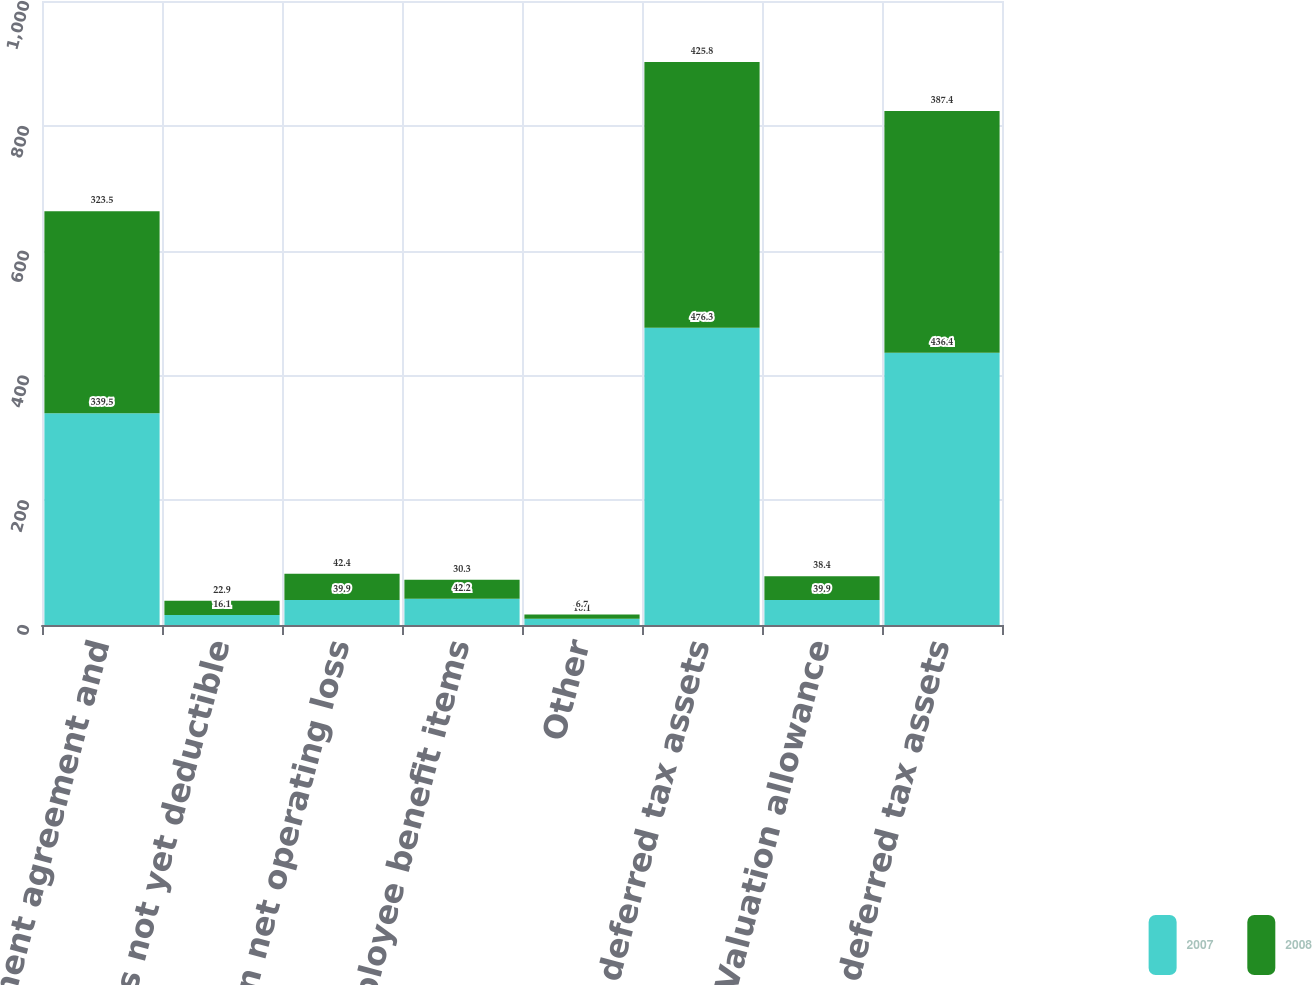Convert chart. <chart><loc_0><loc_0><loc_500><loc_500><stacked_bar_chart><ecel><fcel>Settlement agreement and<fcel>Accruals not yet deductible<fcel>Foreign net operating loss<fcel>Employee benefit items<fcel>Other<fcel>Gross deferred tax assets<fcel>Valuation allowance<fcel>Total deferred tax assets<nl><fcel>2007<fcel>339.5<fcel>16.1<fcel>39.9<fcel>42.2<fcel>10.1<fcel>476.3<fcel>39.9<fcel>436.4<nl><fcel>2008<fcel>323.5<fcel>22.9<fcel>42.4<fcel>30.3<fcel>6.7<fcel>425.8<fcel>38.4<fcel>387.4<nl></chart> 